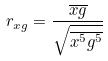<formula> <loc_0><loc_0><loc_500><loc_500>r _ { x g } = \frac { \overline { x g } } { \sqrt { \overline { x ^ { 5 } } \overline { g ^ { 5 } } } }</formula> 